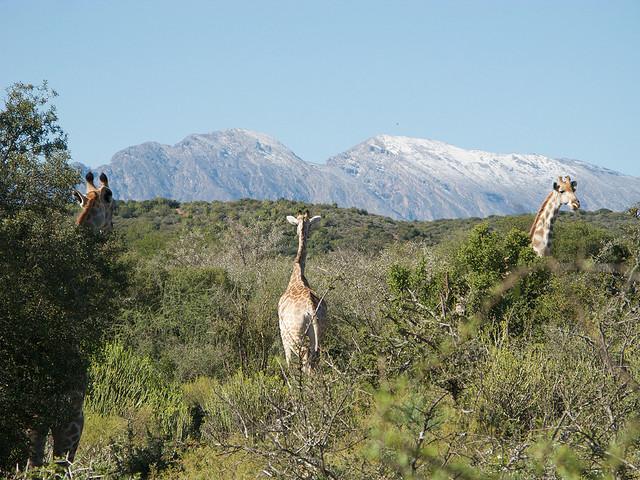What are these animals?
Short answer required. Giraffes. Is there snow on the mountains?
Quick response, please. Yes. What kind of animal is this?
Quick response, please. Giraffe. How many animals are visible?
Answer briefly. 3. Are clouds visible?
Short answer required. No. 